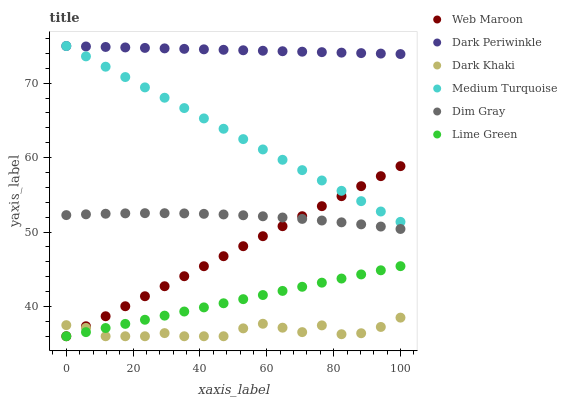Does Dark Khaki have the minimum area under the curve?
Answer yes or no. Yes. Does Dark Periwinkle have the maximum area under the curve?
Answer yes or no. Yes. Does Web Maroon have the minimum area under the curve?
Answer yes or no. No. Does Web Maroon have the maximum area under the curve?
Answer yes or no. No. Is Lime Green the smoothest?
Answer yes or no. Yes. Is Dark Khaki the roughest?
Answer yes or no. Yes. Is Web Maroon the smoothest?
Answer yes or no. No. Is Web Maroon the roughest?
Answer yes or no. No. Does Web Maroon have the lowest value?
Answer yes or no. Yes. Does Medium Turquoise have the lowest value?
Answer yes or no. No. Does Dark Periwinkle have the highest value?
Answer yes or no. Yes. Does Web Maroon have the highest value?
Answer yes or no. No. Is Dark Khaki less than Medium Turquoise?
Answer yes or no. Yes. Is Dark Periwinkle greater than Dim Gray?
Answer yes or no. Yes. Does Dark Khaki intersect Lime Green?
Answer yes or no. Yes. Is Dark Khaki less than Lime Green?
Answer yes or no. No. Is Dark Khaki greater than Lime Green?
Answer yes or no. No. Does Dark Khaki intersect Medium Turquoise?
Answer yes or no. No. 